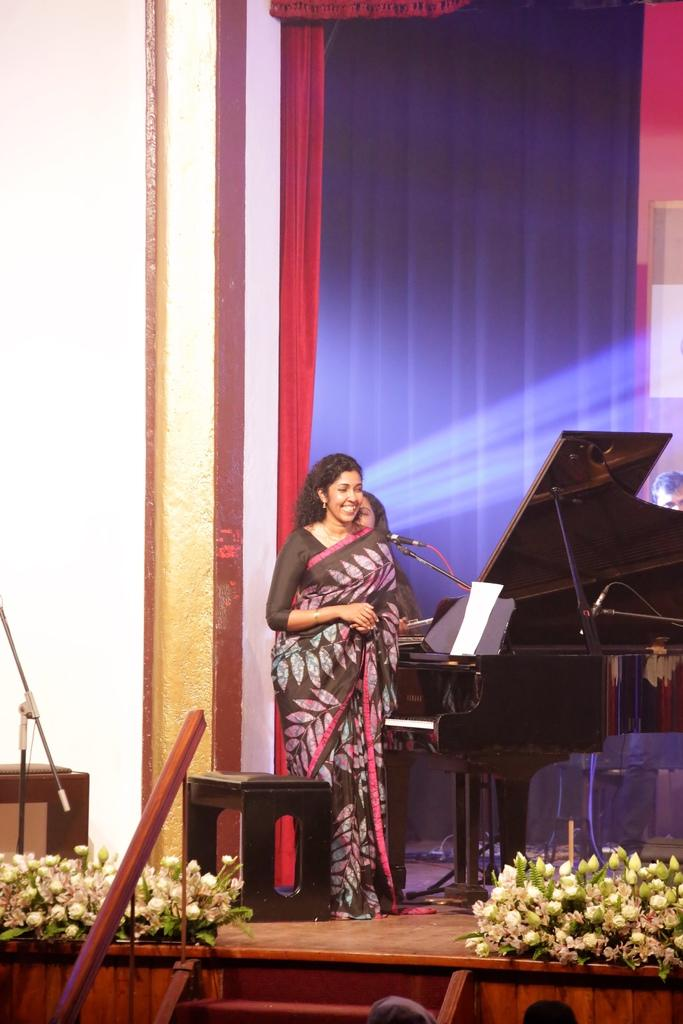How many people are on the stage in the image? There are three persons on the stage in the image. What can be seen in the image besides the people on the stage? There is a musical instrument, a stool, paper, a microphone, flowers, stairs, a curtain, and a wall visible in the image. What type of test can be seen being conducted in the image? There is no test being conducted in the image; it features a stage with people, musical instruments, and other stage elements. Can you spot a rabbit hiding behind the curtain in the image? There is no rabbit present in the image; it only features the people, musical instruments, and other stage elements mentioned earlier. 